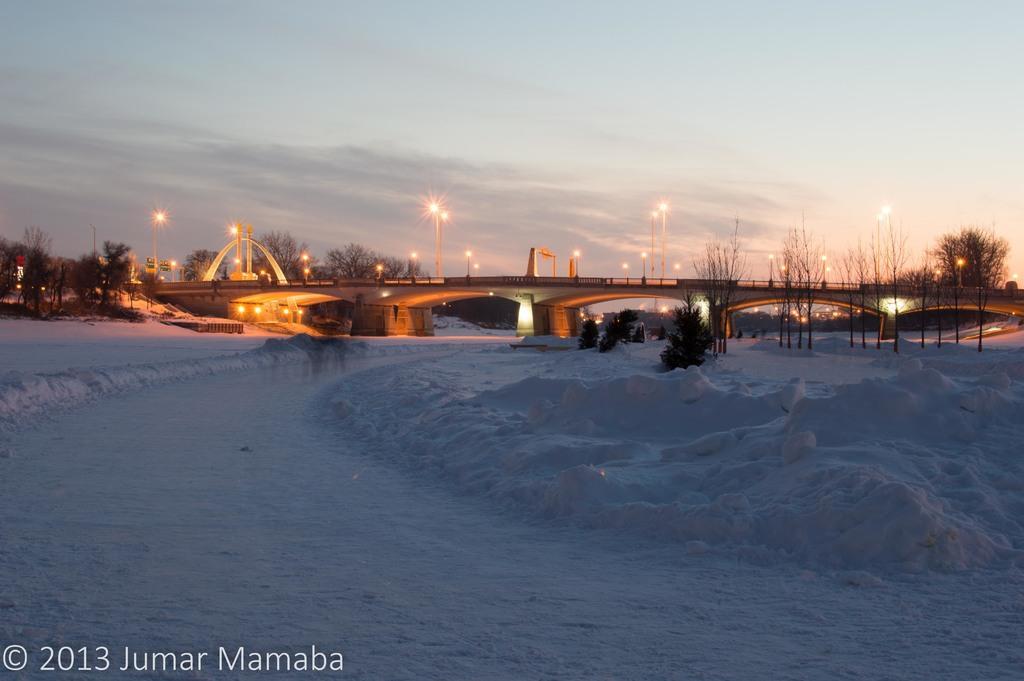Can you describe this image briefly? In the image there is a bridge in the back with street lights on it and below it there is snow all over the land with plants in the back and above its sky with clouds. 